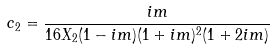<formula> <loc_0><loc_0><loc_500><loc_500>c _ { 2 } = \frac { i m } { 1 6 X _ { 2 } ( 1 - i m ) ( 1 + i m ) ^ { 2 } ( 1 + 2 i m ) }</formula> 